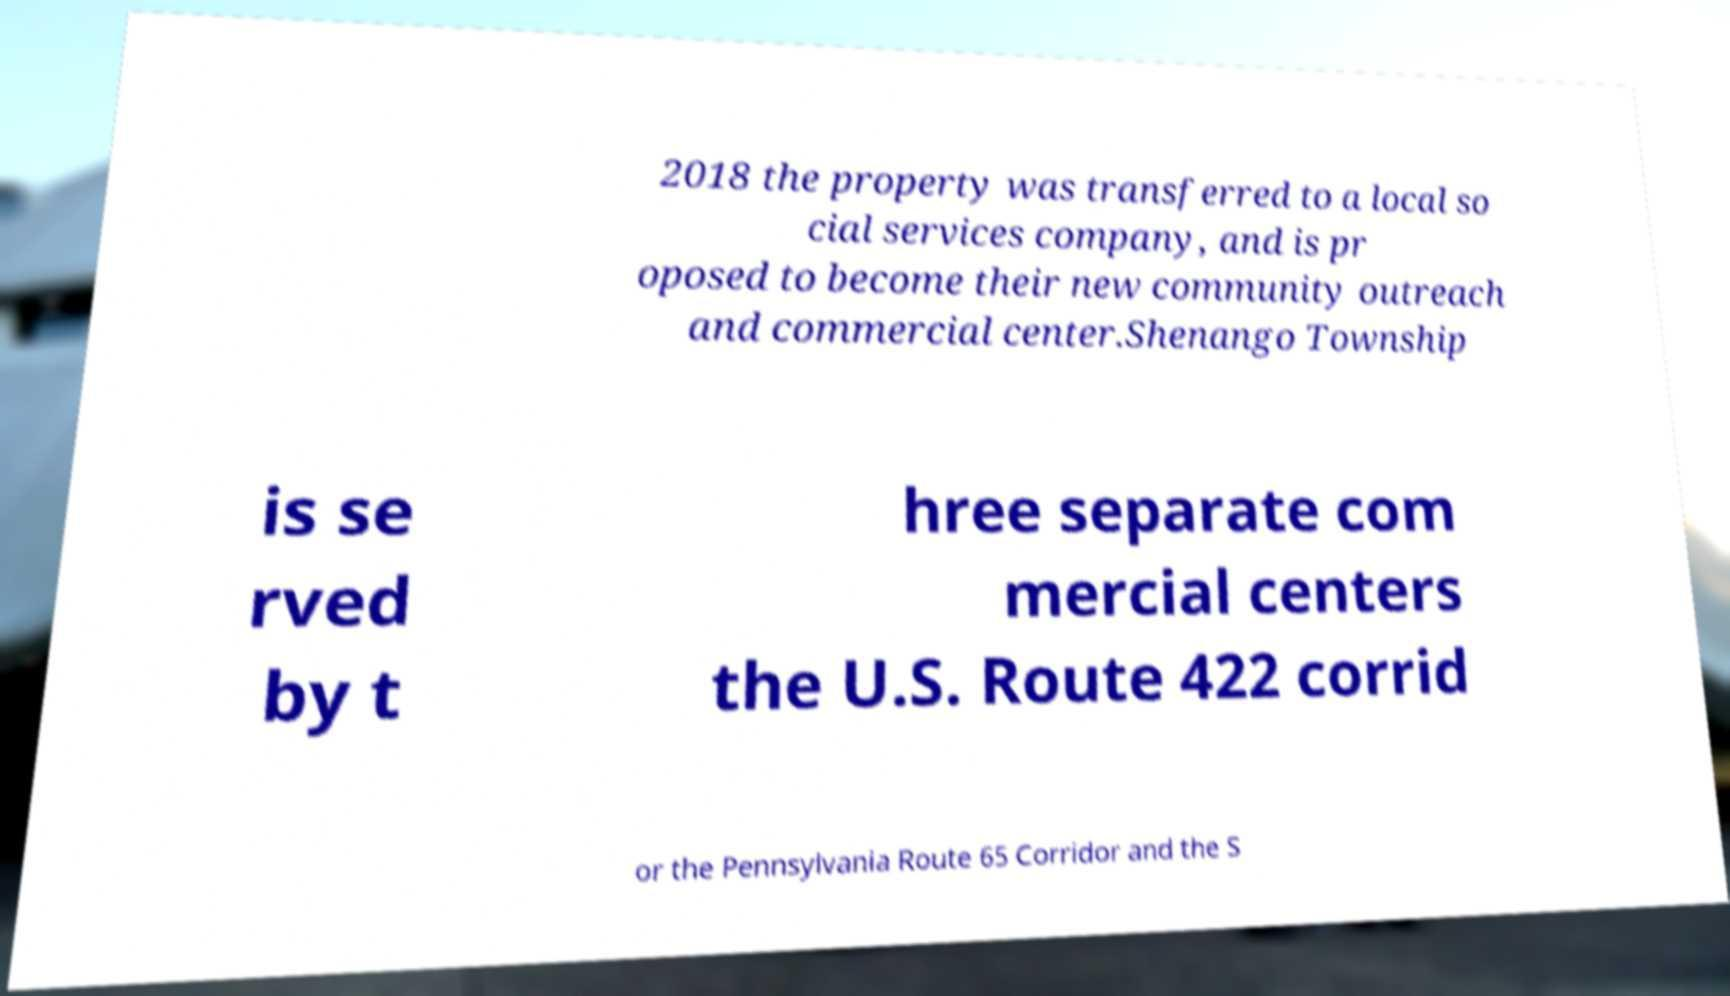What messages or text are displayed in this image? I need them in a readable, typed format. 2018 the property was transferred to a local so cial services company, and is pr oposed to become their new community outreach and commercial center.Shenango Township is se rved by t hree separate com mercial centers the U.S. Route 422 corrid or the Pennsylvania Route 65 Corridor and the S 